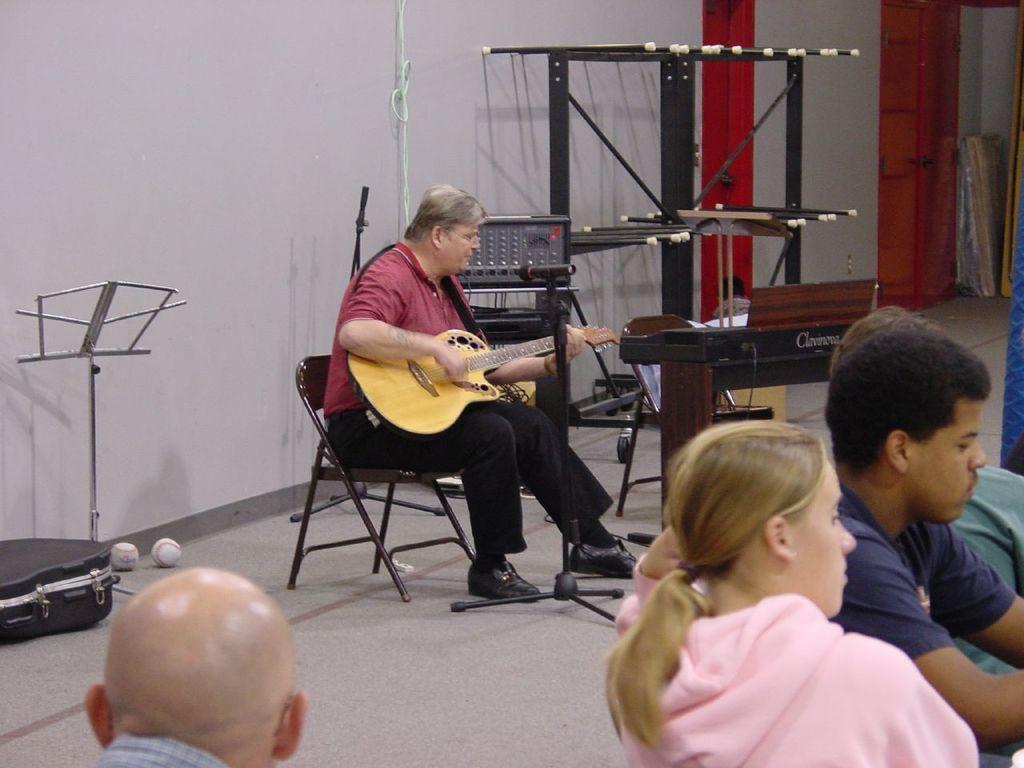Please provide a concise description of this image. A man is seated over a chair playing guitar, in front of him there is a microphone, behind the man there is a wall painted white. On the left corner there are few baseball balls. On right there is a woman in pink hoodie and beside the woman there is a man in blue shirt and on the top right there are few stands and in the center background there is a machine for controlling volumes and the floor is gray in color and on the top right corner there are few wooden objects placed. 